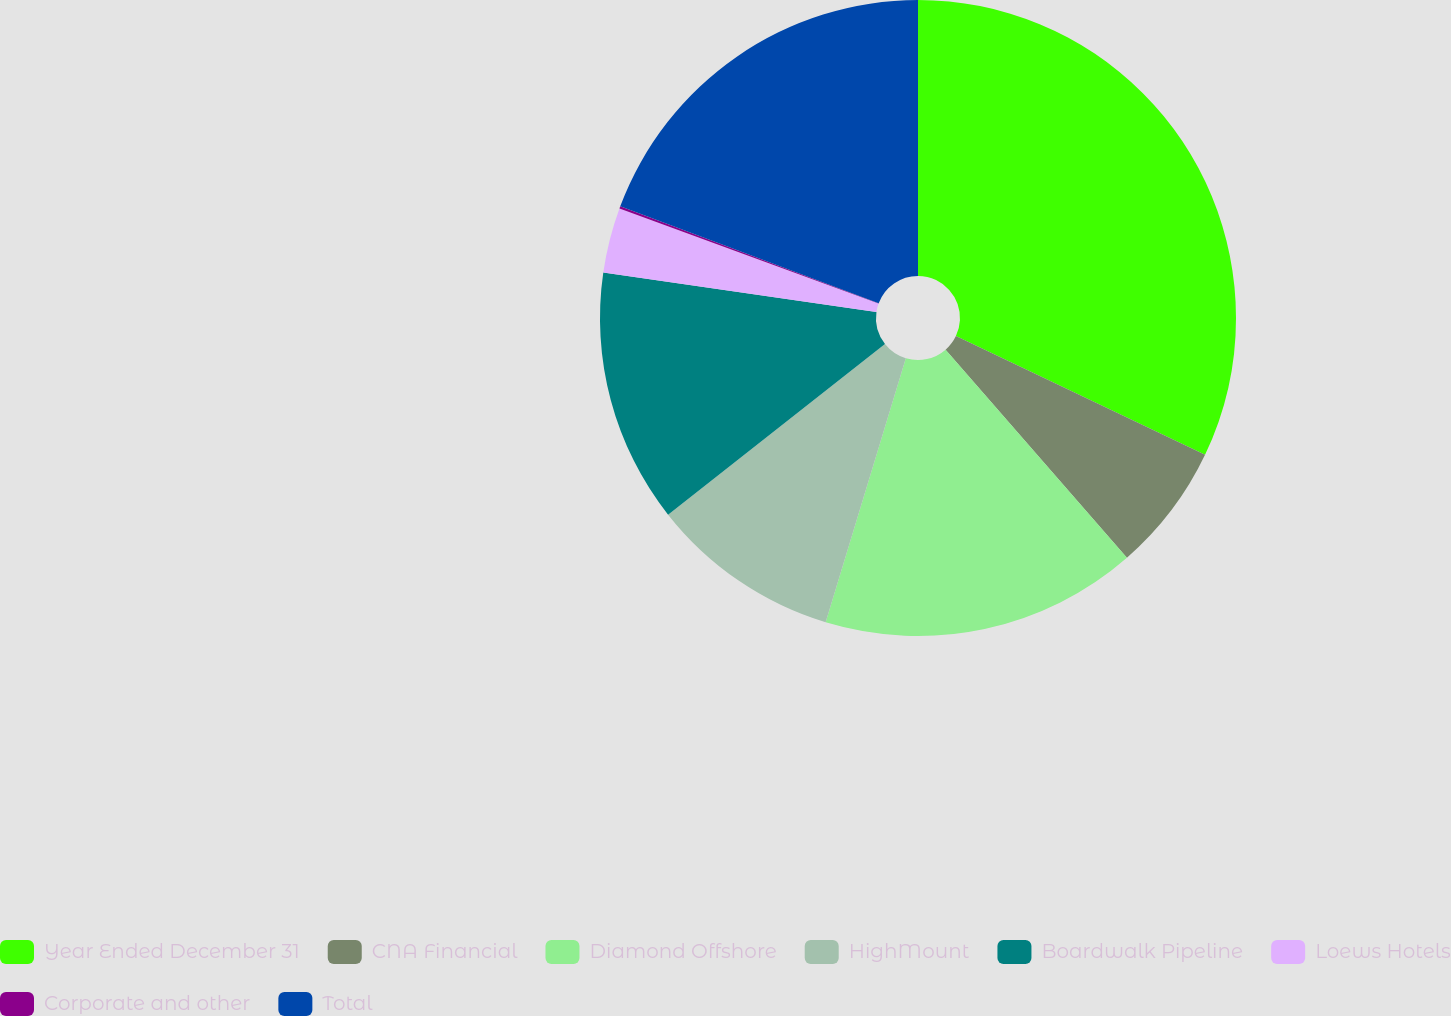Convert chart to OTSL. <chart><loc_0><loc_0><loc_500><loc_500><pie_chart><fcel>Year Ended December 31<fcel>CNA Financial<fcel>Diamond Offshore<fcel>HighMount<fcel>Boardwalk Pipeline<fcel>Loews Hotels<fcel>Corporate and other<fcel>Total<nl><fcel>32.08%<fcel>6.51%<fcel>16.1%<fcel>9.7%<fcel>12.9%<fcel>3.31%<fcel>0.11%<fcel>19.29%<nl></chart> 